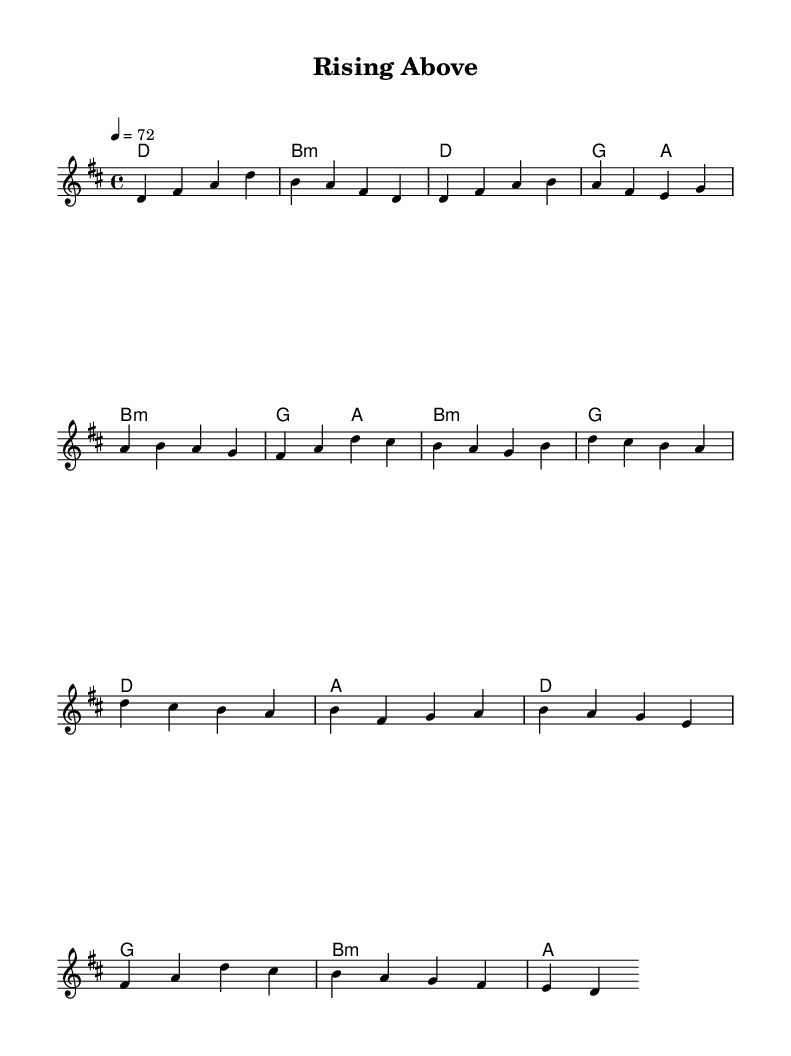What is the key signature of this music? The key signature is D major, which has two sharps (F# and C#).
Answer: D major What is the time signature of this music? The time signature is four-four, which means there are four beats in each measure.
Answer: Four-four What is the tempo of the piece? The tempo marking indicates a speed of seventy-two beats per minute.
Answer: Seventy-two How many measures are in the chorus section? The chorus is made up of four measures, as counted in the sheet music.
Answer: Four measures What is the first chord in the sheet music? The first chord is D major, indicated as a whole note in the harmonies section.
Answer: D major What is the pattern of the verse in terms of melody notes? The verse follows the pattern of notes: D, F#, A, B, A, F#, E, G, A, B, A, G, which represents a melodic contour typical in K-Pop ballads.
Answer: D, F#, A, B, A, F#, E, G, A, B, A, G Which musical elements contribute to the resilience theme in this K-Pop ballad? The use of sustained notes in the melody and the harmonic progression enhances emotional expression, contributing to the theme of resilience.
Answer: Sustained notes and harmonic progression 